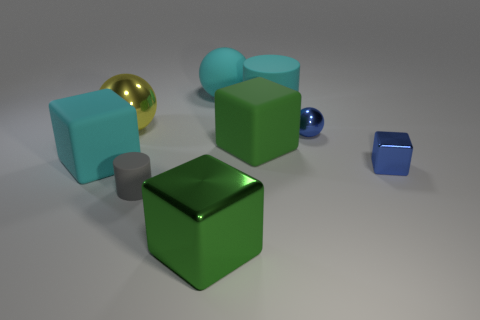Subtract all tiny blue blocks. How many blocks are left? 3 Add 1 metal cubes. How many objects exist? 10 Subtract all yellow balls. How many balls are left? 2 Subtract 1 balls. How many balls are left? 2 Subtract all brown cylinders. How many green cubes are left? 2 Subtract all tiny blue things. Subtract all large metal blocks. How many objects are left? 6 Add 6 tiny blue things. How many tiny blue things are left? 8 Add 5 blue rubber cylinders. How many blue rubber cylinders exist? 5 Subtract 1 cyan balls. How many objects are left? 8 Subtract all cubes. How many objects are left? 5 